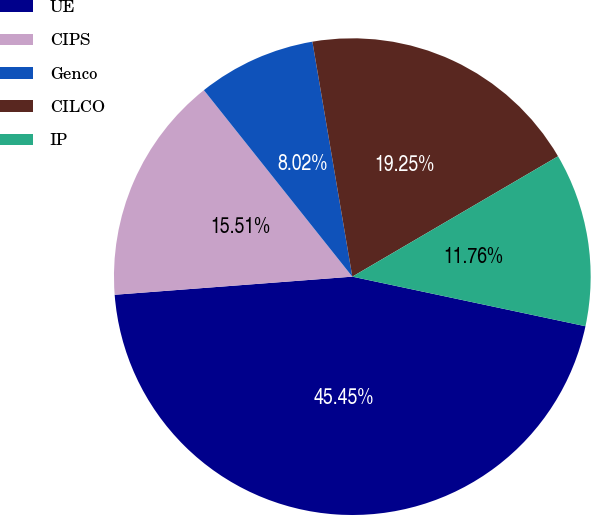Convert chart. <chart><loc_0><loc_0><loc_500><loc_500><pie_chart><fcel>UE<fcel>CIPS<fcel>Genco<fcel>CILCO<fcel>IP<nl><fcel>45.45%<fcel>15.51%<fcel>8.02%<fcel>19.25%<fcel>11.76%<nl></chart> 